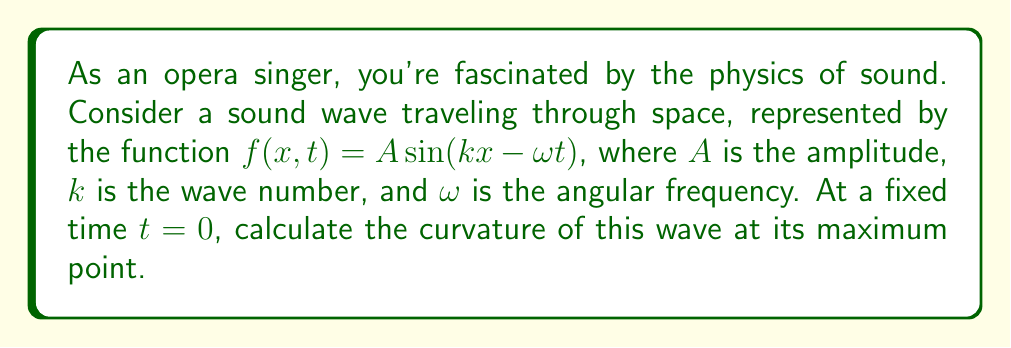Provide a solution to this math problem. Let's approach this step-by-step:

1) At $t=0$, our function becomes $f(x,0) = A \sin(kx)$

2) To find the curvature, we need to calculate:
   $\kappa = \frac{|f''(x)|}{(1+[f'(x)]^2)^{3/2}}$

3) Let's find $f'(x)$ and $f''(x)$:
   $f'(x) = Ak \cos(kx)$
   $f''(x) = -Ak^2 \sin(kx)$

4) The maximum point occurs when $\sin(kx) = 1$, i.e., when $kx = \frac{\pi}{2}$

5) At this point:
   $f'(x) = 0$
   $f''(x) = -Ak^2$

6) Substituting into the curvature formula:
   $\kappa = \frac{|f''(x)|}{(1+[f'(x)]^2)^{3/2}} = \frac{|-Ak^2|}{(1+0^2)^{3/2}} = Ak^2$

Therefore, the curvature at the maximum point is $Ak^2$.

This result shows that the curvature increases with both the amplitude $A$ and the square of the wave number $k$. In musical terms, this means that higher frequency notes (larger $k$) and louder sounds (larger $A$) result in sound waves with greater curvature at their peaks.
Answer: $Ak^2$ 